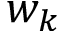<formula> <loc_0><loc_0><loc_500><loc_500>w _ { k }</formula> 